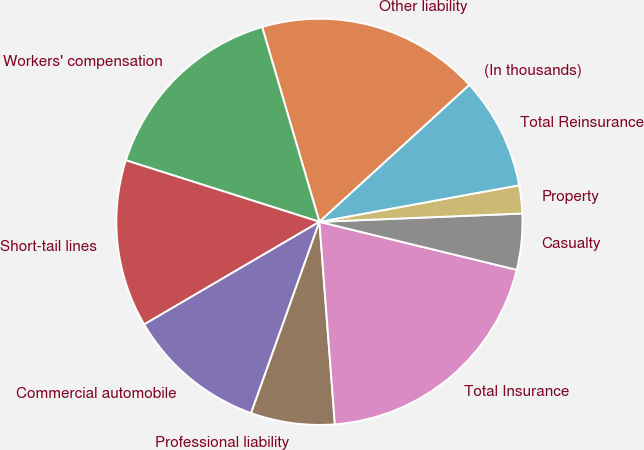Convert chart to OTSL. <chart><loc_0><loc_0><loc_500><loc_500><pie_chart><fcel>(In thousands)<fcel>Other liability<fcel>Workers' compensation<fcel>Short-tail lines<fcel>Commercial automobile<fcel>Professional liability<fcel>Total Insurance<fcel>Casualty<fcel>Property<fcel>Total Reinsurance<nl><fcel>0.01%<fcel>17.77%<fcel>15.55%<fcel>13.33%<fcel>11.11%<fcel>6.67%<fcel>19.99%<fcel>4.45%<fcel>2.23%<fcel>8.89%<nl></chart> 